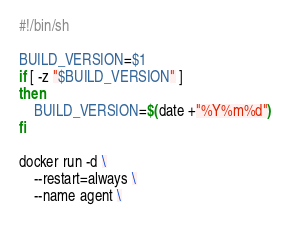Convert code to text. <code><loc_0><loc_0><loc_500><loc_500><_Bash_>#!/bin/sh

BUILD_VERSION=$1
if [ -z "$BUILD_VERSION" ]
then
    BUILD_VERSION=$(date +"%Y%m%d")
fi

docker run -d \
    --restart=always \
    --name agent \</code> 